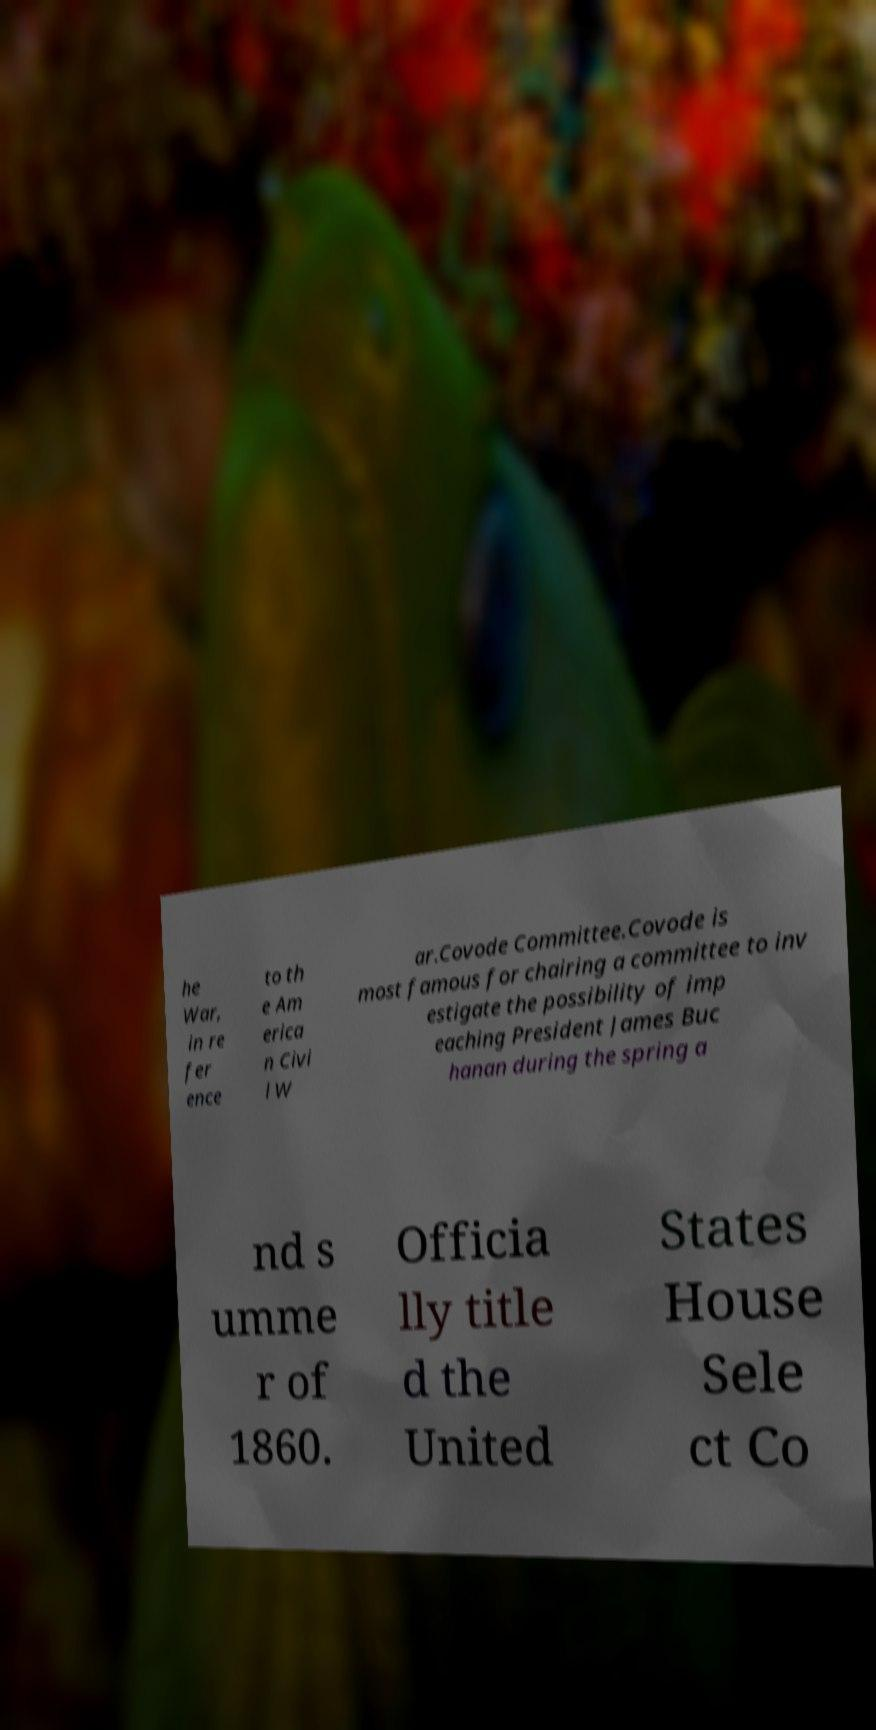For documentation purposes, I need the text within this image transcribed. Could you provide that? he War, in re fer ence to th e Am erica n Civi l W ar.Covode Committee.Covode is most famous for chairing a committee to inv estigate the possibility of imp eaching President James Buc hanan during the spring a nd s umme r of 1860. Officia lly title d the United States House Sele ct Co 